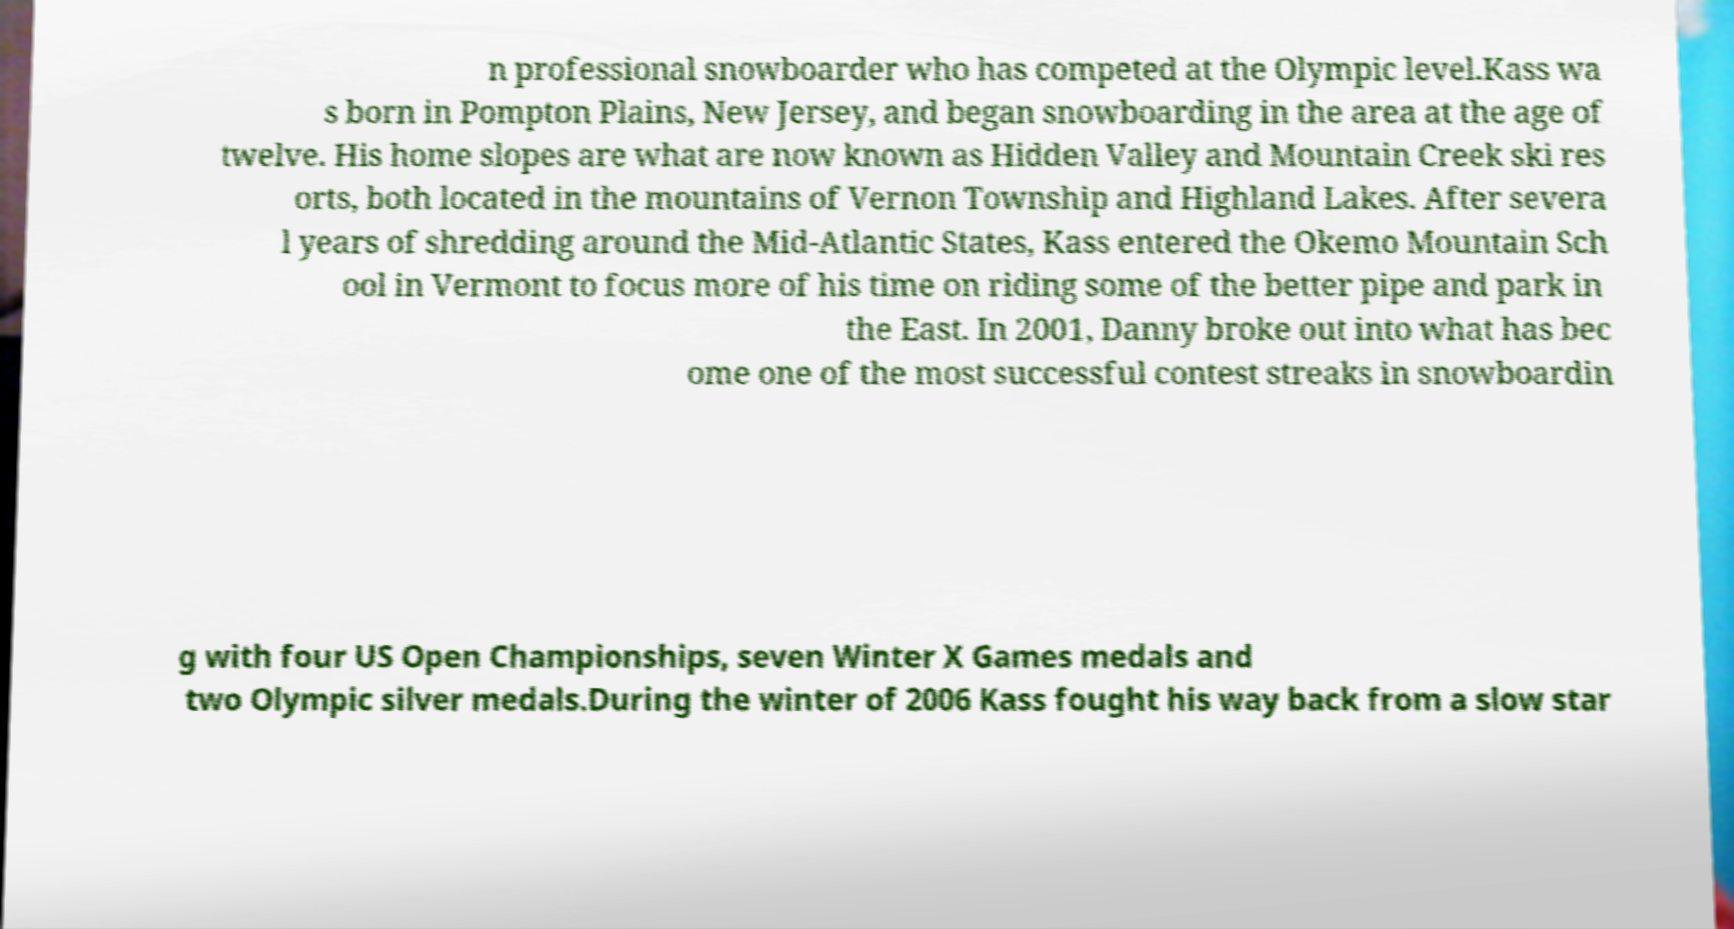What messages or text are displayed in this image? I need them in a readable, typed format. n professional snowboarder who has competed at the Olympic level.Kass wa s born in Pompton Plains, New Jersey, and began snowboarding in the area at the age of twelve. His home slopes are what are now known as Hidden Valley and Mountain Creek ski res orts, both located in the mountains of Vernon Township and Highland Lakes. After severa l years of shredding around the Mid-Atlantic States, Kass entered the Okemo Mountain Sch ool in Vermont to focus more of his time on riding some of the better pipe and park in the East. In 2001, Danny broke out into what has bec ome one of the most successful contest streaks in snowboardin g with four US Open Championships, seven Winter X Games medals and two Olympic silver medals.During the winter of 2006 Kass fought his way back from a slow star 